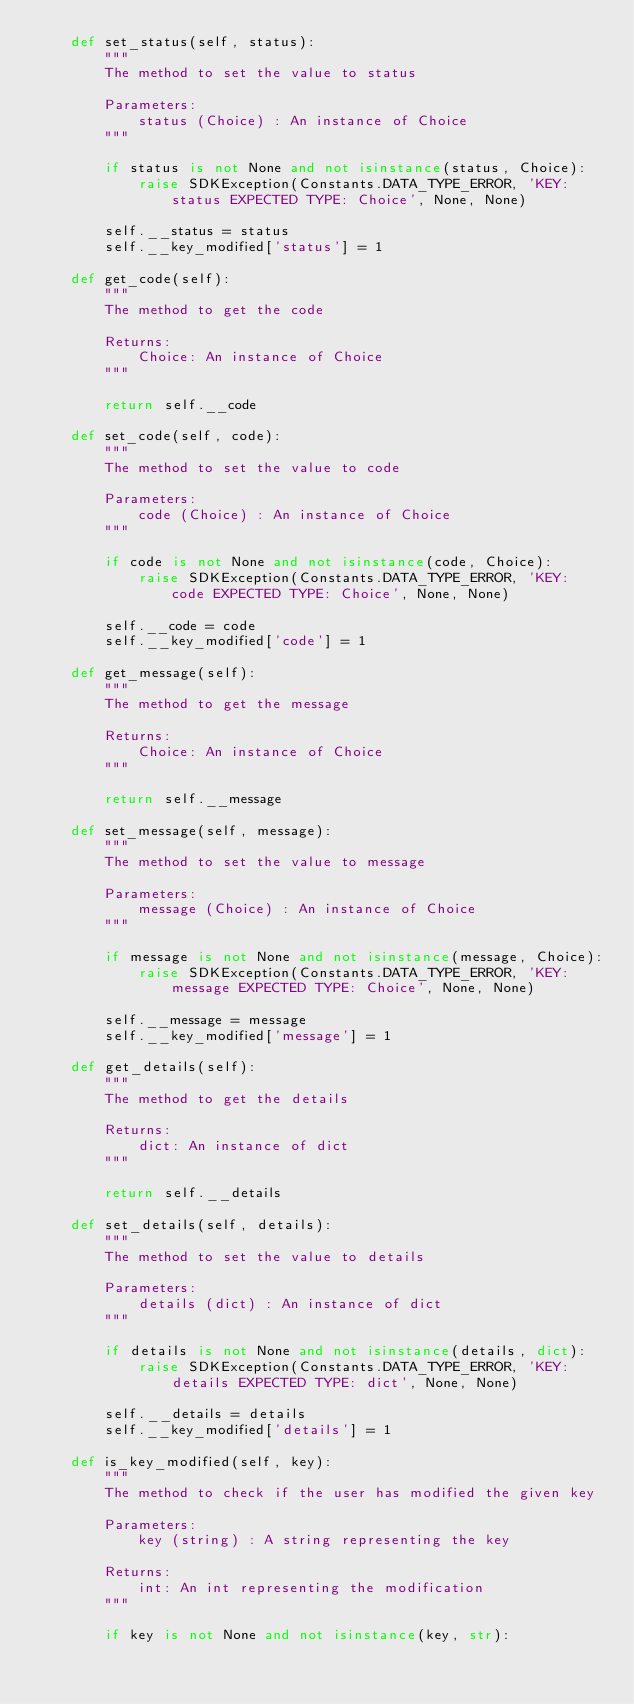<code> <loc_0><loc_0><loc_500><loc_500><_Python_>	def set_status(self, status):
		"""
		The method to set the value to status

		Parameters:
			status (Choice) : An instance of Choice
		"""

		if status is not None and not isinstance(status, Choice):
			raise SDKException(Constants.DATA_TYPE_ERROR, 'KEY: status EXPECTED TYPE: Choice', None, None)
		
		self.__status = status
		self.__key_modified['status'] = 1

	def get_code(self):
		"""
		The method to get the code

		Returns:
			Choice: An instance of Choice
		"""

		return self.__code

	def set_code(self, code):
		"""
		The method to set the value to code

		Parameters:
			code (Choice) : An instance of Choice
		"""

		if code is not None and not isinstance(code, Choice):
			raise SDKException(Constants.DATA_TYPE_ERROR, 'KEY: code EXPECTED TYPE: Choice', None, None)
		
		self.__code = code
		self.__key_modified['code'] = 1

	def get_message(self):
		"""
		The method to get the message

		Returns:
			Choice: An instance of Choice
		"""

		return self.__message

	def set_message(self, message):
		"""
		The method to set the value to message

		Parameters:
			message (Choice) : An instance of Choice
		"""

		if message is not None and not isinstance(message, Choice):
			raise SDKException(Constants.DATA_TYPE_ERROR, 'KEY: message EXPECTED TYPE: Choice', None, None)
		
		self.__message = message
		self.__key_modified['message'] = 1

	def get_details(self):
		"""
		The method to get the details

		Returns:
			dict: An instance of dict
		"""

		return self.__details

	def set_details(self, details):
		"""
		The method to set the value to details

		Parameters:
			details (dict) : An instance of dict
		"""

		if details is not None and not isinstance(details, dict):
			raise SDKException(Constants.DATA_TYPE_ERROR, 'KEY: details EXPECTED TYPE: dict', None, None)
		
		self.__details = details
		self.__key_modified['details'] = 1

	def is_key_modified(self, key):
		"""
		The method to check if the user has modified the given key

		Parameters:
			key (string) : A string representing the key

		Returns:
			int: An int representing the modification
		"""

		if key is not None and not isinstance(key, str):</code> 